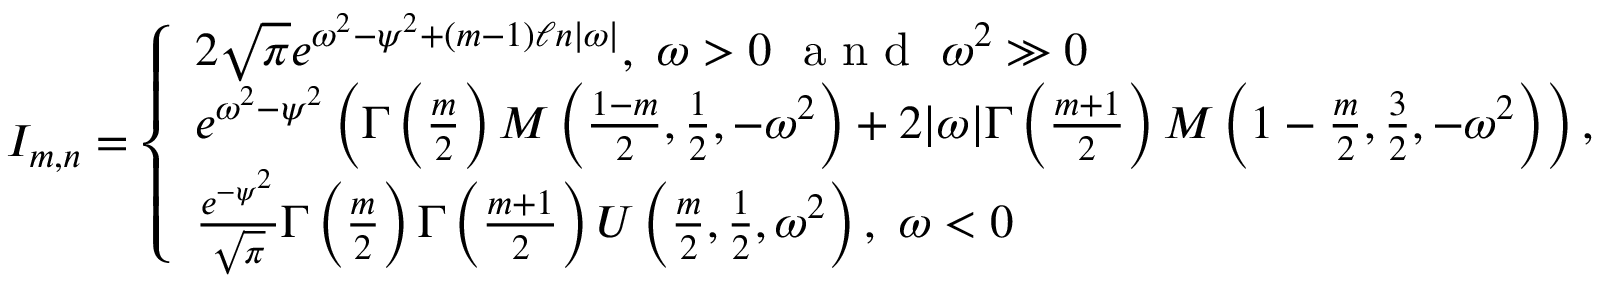<formula> <loc_0><loc_0><loc_500><loc_500>\begin{array} { r } { I _ { m , n } = \left \{ \begin{array} { l l } { 2 \sqrt { \pi } e ^ { \omega ^ { 2 } - \psi ^ { 2 } + ( m - 1 ) \ell n | \omega | } , \ \omega > 0 \ a n d \ \omega ^ { 2 } \gg 0 } \\ { e ^ { \omega ^ { 2 } - \psi ^ { 2 } } \left ( \Gamma \left ( \frac { m } { 2 } \right ) M \left ( \frac { 1 - m } { 2 } , \frac { 1 } { 2 } , - \omega ^ { 2 } \right ) + 2 | \omega | \Gamma \left ( \frac { m + 1 } { 2 } \right ) M \left ( 1 - \frac { m } { 2 } , \frac { 3 } { 2 } , - \omega ^ { 2 } \right ) \right ) , \ \omega > 0 } \\ { \frac { e ^ { - \psi ^ { 2 } } } { \sqrt { \pi } } \Gamma \left ( \frac { m } { 2 } \right ) \Gamma \left ( \frac { m + 1 } { 2 } \right ) U \left ( \frac { m } { 2 } , \frac { 1 } { 2 } , \omega ^ { 2 } \right ) , \ \omega < 0 } \end{array} } \end{array}</formula> 